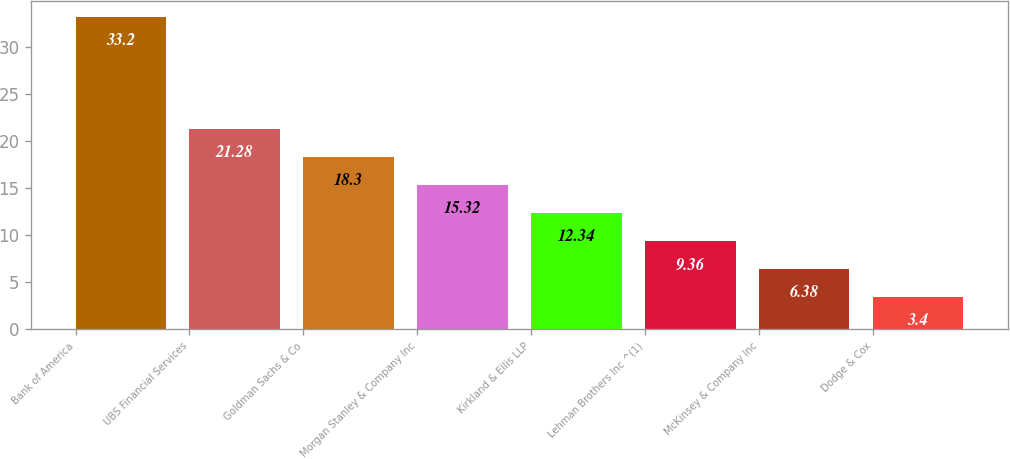Convert chart. <chart><loc_0><loc_0><loc_500><loc_500><bar_chart><fcel>Bank of America<fcel>UBS Financial Services<fcel>Goldman Sachs & Co<fcel>Morgan Stanley & Company Inc<fcel>Kirkland & Ellis LLP<fcel>Lehman Brothers Inc ^(1)<fcel>McKinsey & Company Inc<fcel>Dodge & Cox<nl><fcel>33.2<fcel>21.28<fcel>18.3<fcel>15.32<fcel>12.34<fcel>9.36<fcel>6.38<fcel>3.4<nl></chart> 